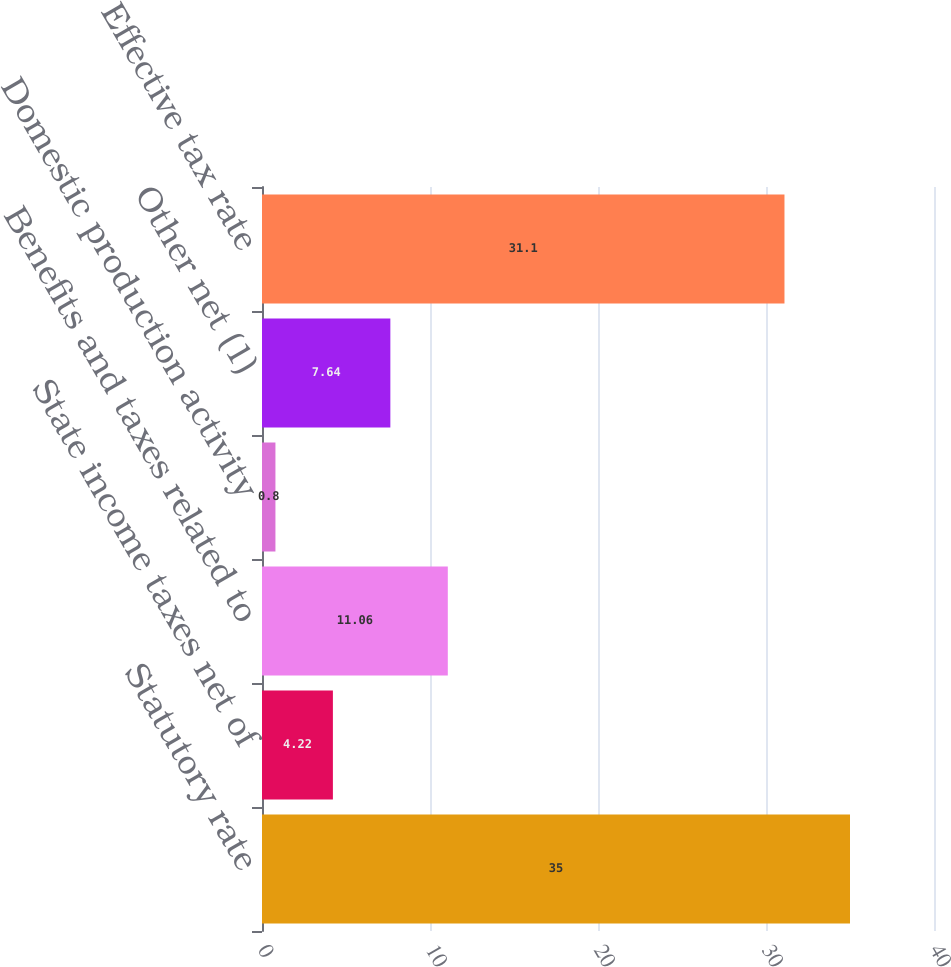<chart> <loc_0><loc_0><loc_500><loc_500><bar_chart><fcel>Statutory rate<fcel>State income taxes net of<fcel>Benefits and taxes related to<fcel>Domestic production activity<fcel>Other net (1)<fcel>Effective tax rate<nl><fcel>35<fcel>4.22<fcel>11.06<fcel>0.8<fcel>7.64<fcel>31.1<nl></chart> 